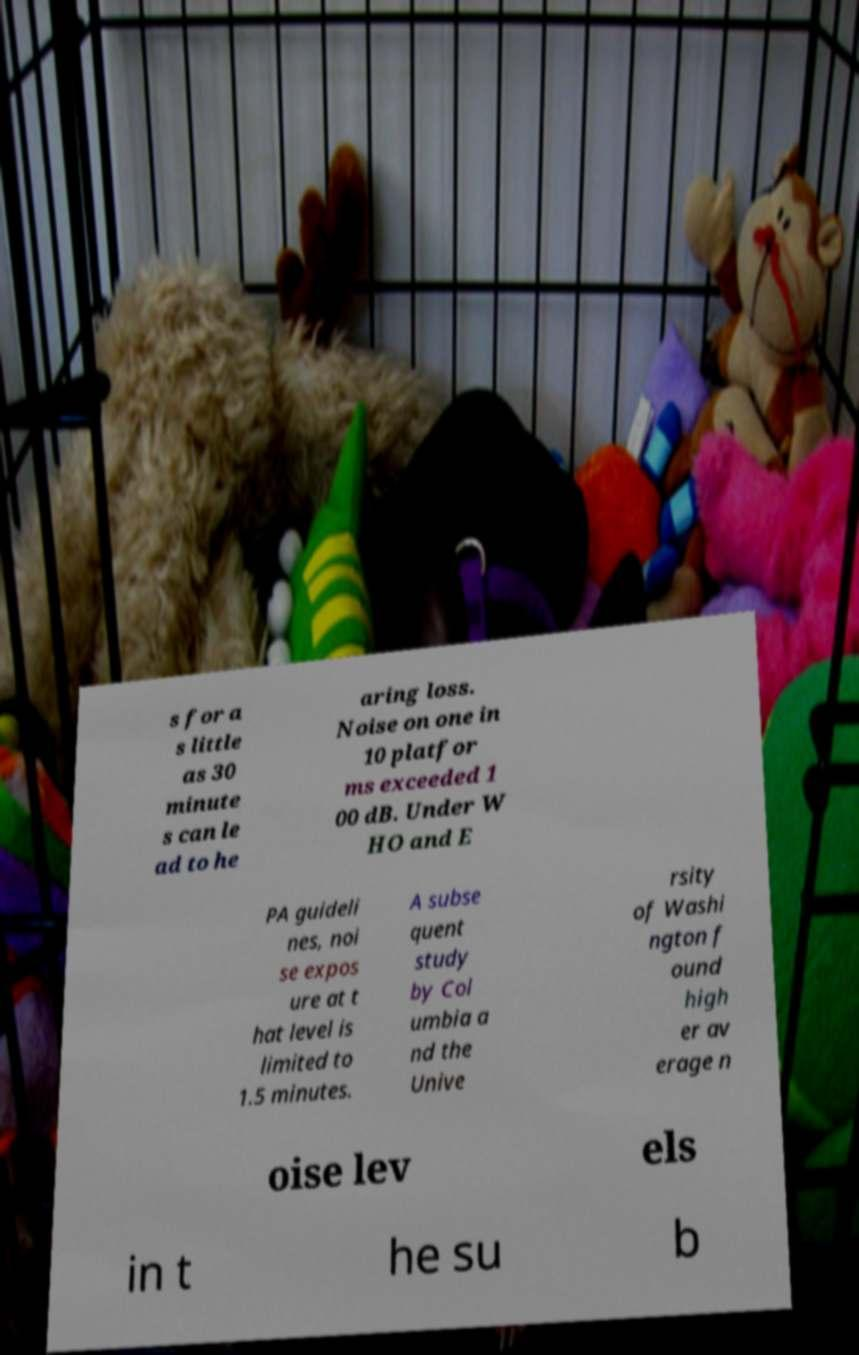Could you assist in decoding the text presented in this image and type it out clearly? s for a s little as 30 minute s can le ad to he aring loss. Noise on one in 10 platfor ms exceeded 1 00 dB. Under W HO and E PA guideli nes, noi se expos ure at t hat level is limited to 1.5 minutes. A subse quent study by Col umbia a nd the Unive rsity of Washi ngton f ound high er av erage n oise lev els in t he su b 